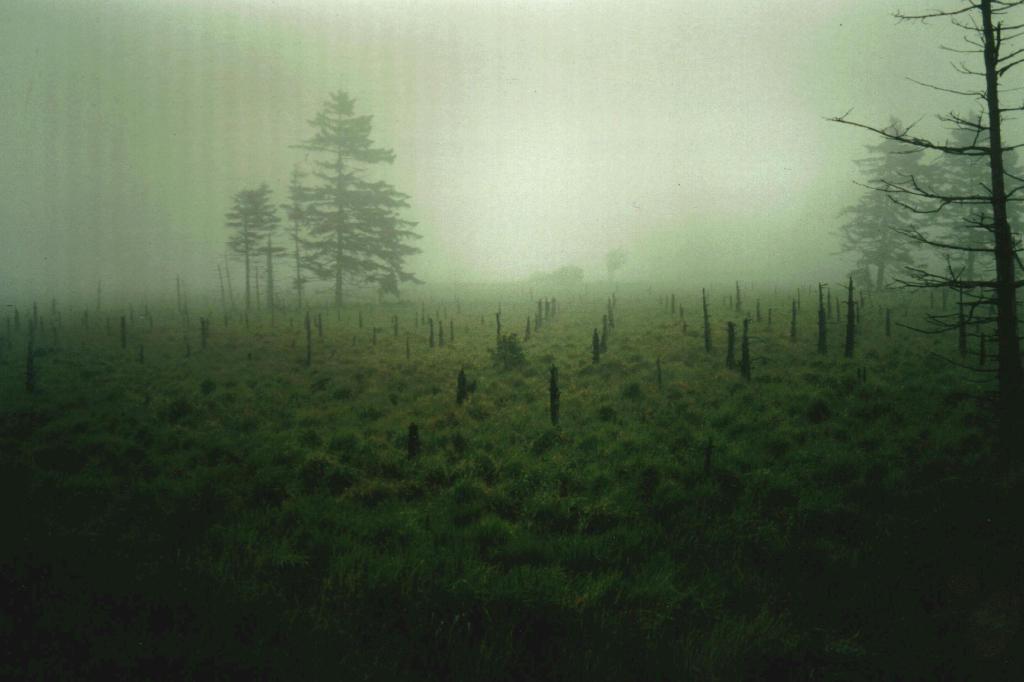Describe this image in one or two sentences. In this image there is grass. There are wooden sticks. There are trees. There is a sky. 